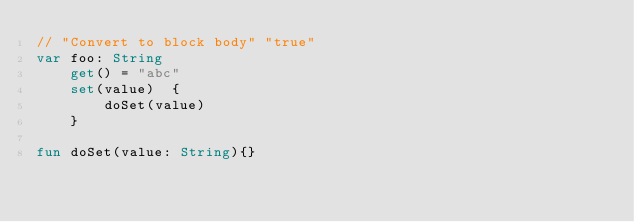<code> <loc_0><loc_0><loc_500><loc_500><_Kotlin_>// "Convert to block body" "true"
var foo: String
    get() = "abc"
    set(value)  {
        doSet(value)
    }

fun doSet(value: String){}</code> 